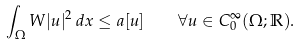Convert formula to latex. <formula><loc_0><loc_0><loc_500><loc_500>\int _ { \Omega } W | u | ^ { 2 } \, d x \leq a [ u ] \quad \forall u \in C _ { 0 } ^ { \infty } ( \Omega ; \mathbb { R } ) .</formula> 